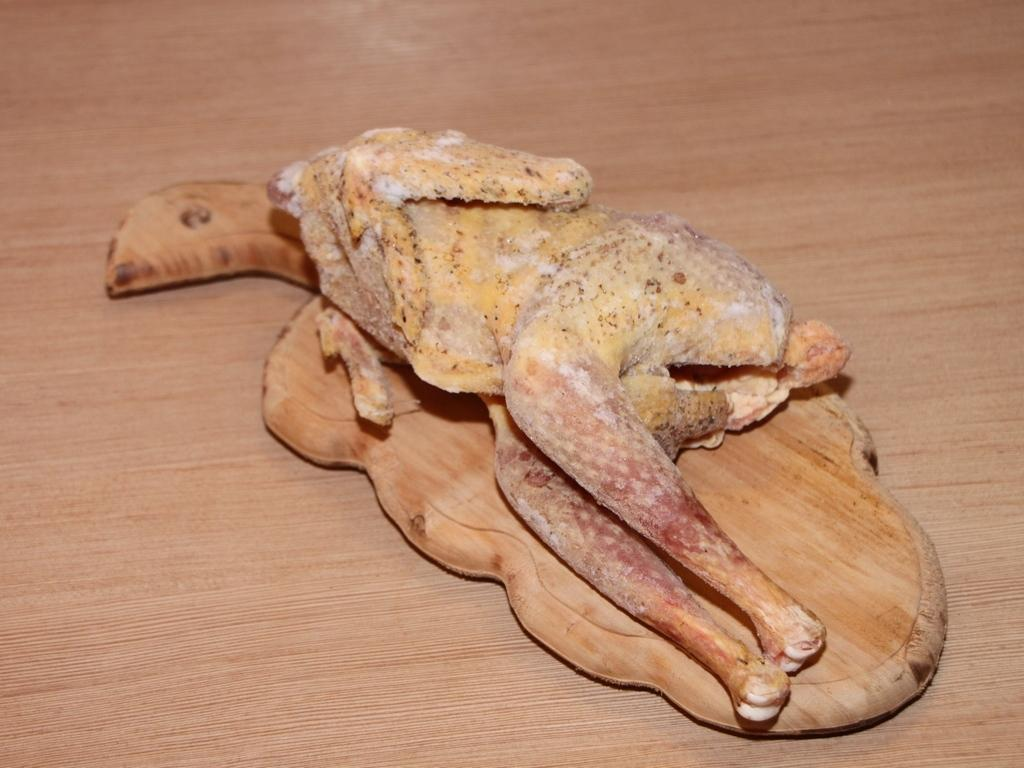What animal is on the chopping board in the image? There is a chicken on a chopping board in the image. Where is the chopping board located? The chopping board is on a table. What type of fan can be seen in the image? There is no fan present in the image. How many ducks are visible in the image? There are no ducks present in the image. 